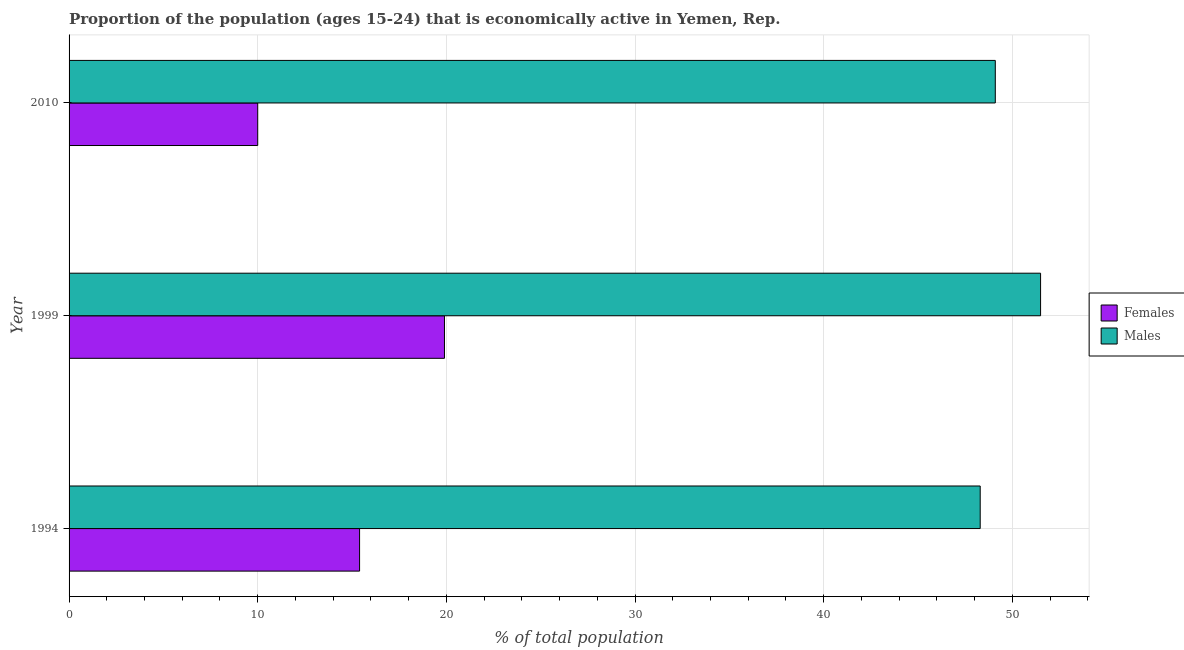Are the number of bars per tick equal to the number of legend labels?
Make the answer very short. Yes. Are the number of bars on each tick of the Y-axis equal?
Your response must be concise. Yes. In how many cases, is the number of bars for a given year not equal to the number of legend labels?
Offer a terse response. 0. What is the percentage of economically active male population in 1994?
Keep it short and to the point. 48.3. Across all years, what is the maximum percentage of economically active female population?
Your answer should be very brief. 19.9. In which year was the percentage of economically active male population minimum?
Keep it short and to the point. 1994. What is the total percentage of economically active female population in the graph?
Offer a very short reply. 45.3. What is the difference between the percentage of economically active female population in 1994 and that in 1999?
Your answer should be compact. -4.5. What is the difference between the percentage of economically active male population in 1994 and the percentage of economically active female population in 1999?
Give a very brief answer. 28.4. What is the average percentage of economically active male population per year?
Offer a terse response. 49.63. In the year 1999, what is the difference between the percentage of economically active female population and percentage of economically active male population?
Make the answer very short. -31.6. In how many years, is the percentage of economically active male population greater than 30 %?
Give a very brief answer. 3. What is the ratio of the percentage of economically active female population in 1994 to that in 2010?
Your answer should be compact. 1.54. Is the difference between the percentage of economically active female population in 1994 and 2010 greater than the difference between the percentage of economically active male population in 1994 and 2010?
Give a very brief answer. Yes. What is the difference between the highest and the second highest percentage of economically active male population?
Give a very brief answer. 2.4. In how many years, is the percentage of economically active male population greater than the average percentage of economically active male population taken over all years?
Offer a very short reply. 1. What does the 2nd bar from the top in 1999 represents?
Ensure brevity in your answer.  Females. What does the 2nd bar from the bottom in 2010 represents?
Give a very brief answer. Males. How many bars are there?
Your response must be concise. 6. What is the difference between two consecutive major ticks on the X-axis?
Provide a succinct answer. 10. Are the values on the major ticks of X-axis written in scientific E-notation?
Make the answer very short. No. Does the graph contain grids?
Ensure brevity in your answer.  Yes. Where does the legend appear in the graph?
Your answer should be compact. Center right. How many legend labels are there?
Offer a terse response. 2. How are the legend labels stacked?
Ensure brevity in your answer.  Vertical. What is the title of the graph?
Provide a succinct answer. Proportion of the population (ages 15-24) that is economically active in Yemen, Rep. Does "Infant" appear as one of the legend labels in the graph?
Your answer should be compact. No. What is the label or title of the X-axis?
Your response must be concise. % of total population. What is the label or title of the Y-axis?
Give a very brief answer. Year. What is the % of total population of Females in 1994?
Keep it short and to the point. 15.4. What is the % of total population of Males in 1994?
Ensure brevity in your answer.  48.3. What is the % of total population in Females in 1999?
Your answer should be compact. 19.9. What is the % of total population in Males in 1999?
Provide a succinct answer. 51.5. What is the % of total population of Males in 2010?
Ensure brevity in your answer.  49.1. Across all years, what is the maximum % of total population in Females?
Your answer should be compact. 19.9. Across all years, what is the maximum % of total population in Males?
Your response must be concise. 51.5. Across all years, what is the minimum % of total population of Males?
Give a very brief answer. 48.3. What is the total % of total population of Females in the graph?
Your response must be concise. 45.3. What is the total % of total population in Males in the graph?
Keep it short and to the point. 148.9. What is the difference between the % of total population of Females in 1994 and that in 1999?
Offer a very short reply. -4.5. What is the difference between the % of total population of Males in 1994 and that in 1999?
Your response must be concise. -3.2. What is the difference between the % of total population of Females in 1994 and that in 2010?
Keep it short and to the point. 5.4. What is the difference between the % of total population in Females in 1994 and the % of total population in Males in 1999?
Your answer should be very brief. -36.1. What is the difference between the % of total population in Females in 1994 and the % of total population in Males in 2010?
Your response must be concise. -33.7. What is the difference between the % of total population of Females in 1999 and the % of total population of Males in 2010?
Offer a very short reply. -29.2. What is the average % of total population in Males per year?
Offer a terse response. 49.63. In the year 1994, what is the difference between the % of total population of Females and % of total population of Males?
Keep it short and to the point. -32.9. In the year 1999, what is the difference between the % of total population in Females and % of total population in Males?
Offer a very short reply. -31.6. In the year 2010, what is the difference between the % of total population in Females and % of total population in Males?
Keep it short and to the point. -39.1. What is the ratio of the % of total population in Females in 1994 to that in 1999?
Keep it short and to the point. 0.77. What is the ratio of the % of total population in Males in 1994 to that in 1999?
Keep it short and to the point. 0.94. What is the ratio of the % of total population in Females in 1994 to that in 2010?
Provide a short and direct response. 1.54. What is the ratio of the % of total population of Males in 1994 to that in 2010?
Make the answer very short. 0.98. What is the ratio of the % of total population of Females in 1999 to that in 2010?
Keep it short and to the point. 1.99. What is the ratio of the % of total population in Males in 1999 to that in 2010?
Offer a terse response. 1.05. What is the difference between the highest and the second highest % of total population in Males?
Provide a short and direct response. 2.4. 